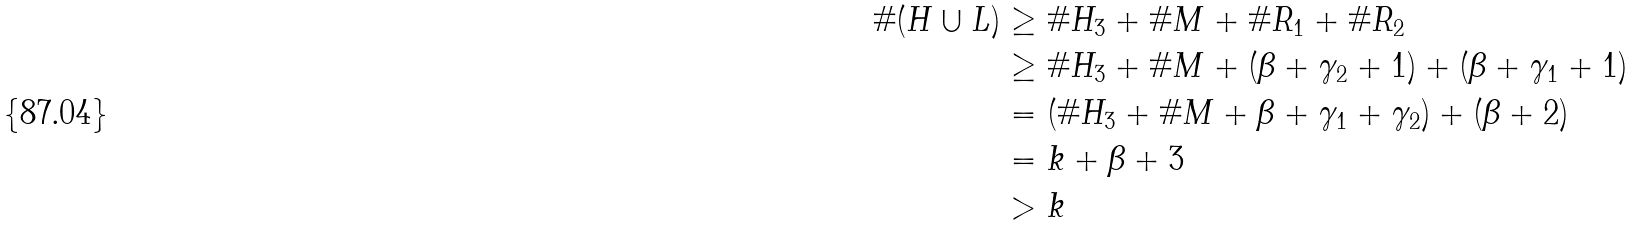<formula> <loc_0><loc_0><loc_500><loc_500>\# ( H \cup L ) & \geq \# H _ { 3 } + \# M + \# R _ { 1 } + \# R _ { 2 } \\ & \geq \# H _ { 3 } + \# M + ( \beta + \gamma _ { 2 } + 1 ) + ( \beta + \gamma _ { 1 } + 1 ) \\ & = ( \# H _ { 3 } + \# M + \beta + \gamma _ { 1 } + \gamma _ { 2 } ) + ( \beta + 2 ) \\ & = k + \beta + 3 \\ & > k</formula> 